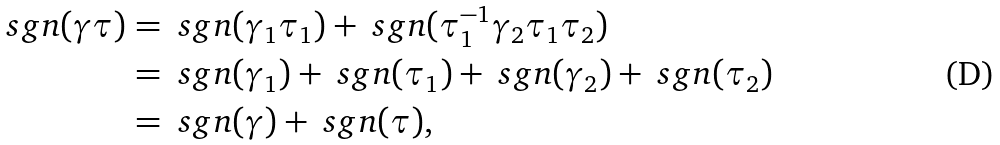<formula> <loc_0><loc_0><loc_500><loc_500>\ s g n ( \gamma \tau ) & = \ s g n ( \gamma _ { 1 } \tau _ { 1 } ) + \ s g n ( \tau _ { 1 } ^ { - 1 } \gamma _ { 2 } \tau _ { 1 } \tau _ { 2 } ) \\ & = \ s g n ( \gamma _ { 1 } ) + \ s g n ( \tau _ { 1 } ) + \ s g n ( \gamma _ { 2 } ) + \ s g n ( \tau _ { 2 } ) \\ & = \ s g n ( \gamma ) + \ s g n ( \tau ) ,</formula> 